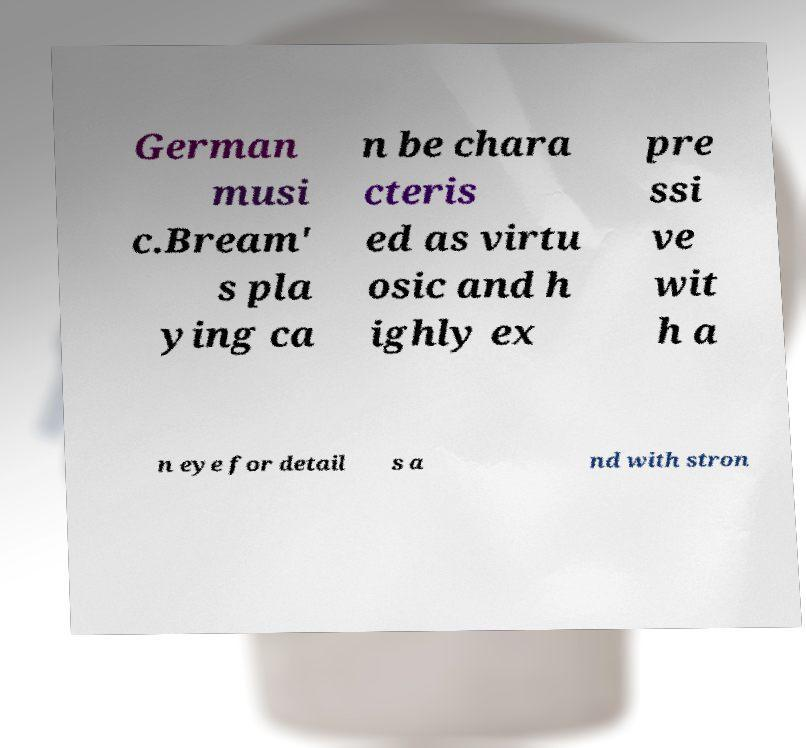There's text embedded in this image that I need extracted. Can you transcribe it verbatim? German musi c.Bream' s pla ying ca n be chara cteris ed as virtu osic and h ighly ex pre ssi ve wit h a n eye for detail s a nd with stron 